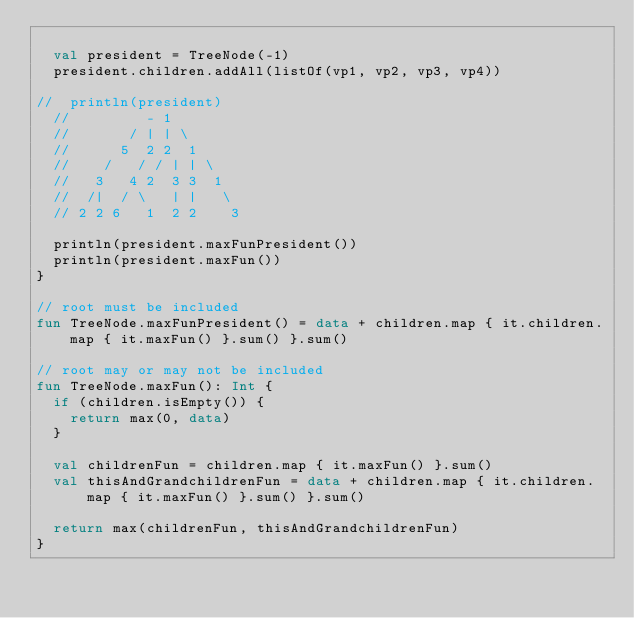<code> <loc_0><loc_0><loc_500><loc_500><_Kotlin_>
	val president = TreeNode(-1)
	president.children.addAll(listOf(vp1, vp2, vp3, vp4))

//	println(president)
	//         - 1
	//       / | | \
	//      5  2 2  1
	//    /   / / | | \
	//   3   4 2  3 3  1
	//  /|  / \   | |   \
	// 2 2 6   1  2 2    3

	println(president.maxFunPresident())
	println(president.maxFun())
}

// root must be included
fun TreeNode.maxFunPresident() = data + children.map { it.children.map { it.maxFun() }.sum() }.sum()

// root may or may not be included
fun TreeNode.maxFun(): Int {
	if (children.isEmpty()) {
		return max(0, data)
	}

	val childrenFun = children.map { it.maxFun() }.sum()
	val thisAndGrandchildrenFun = data + children.map { it.children.map { it.maxFun() }.sum() }.sum()

	return max(childrenFun, thisAndGrandchildrenFun)
}
</code> 